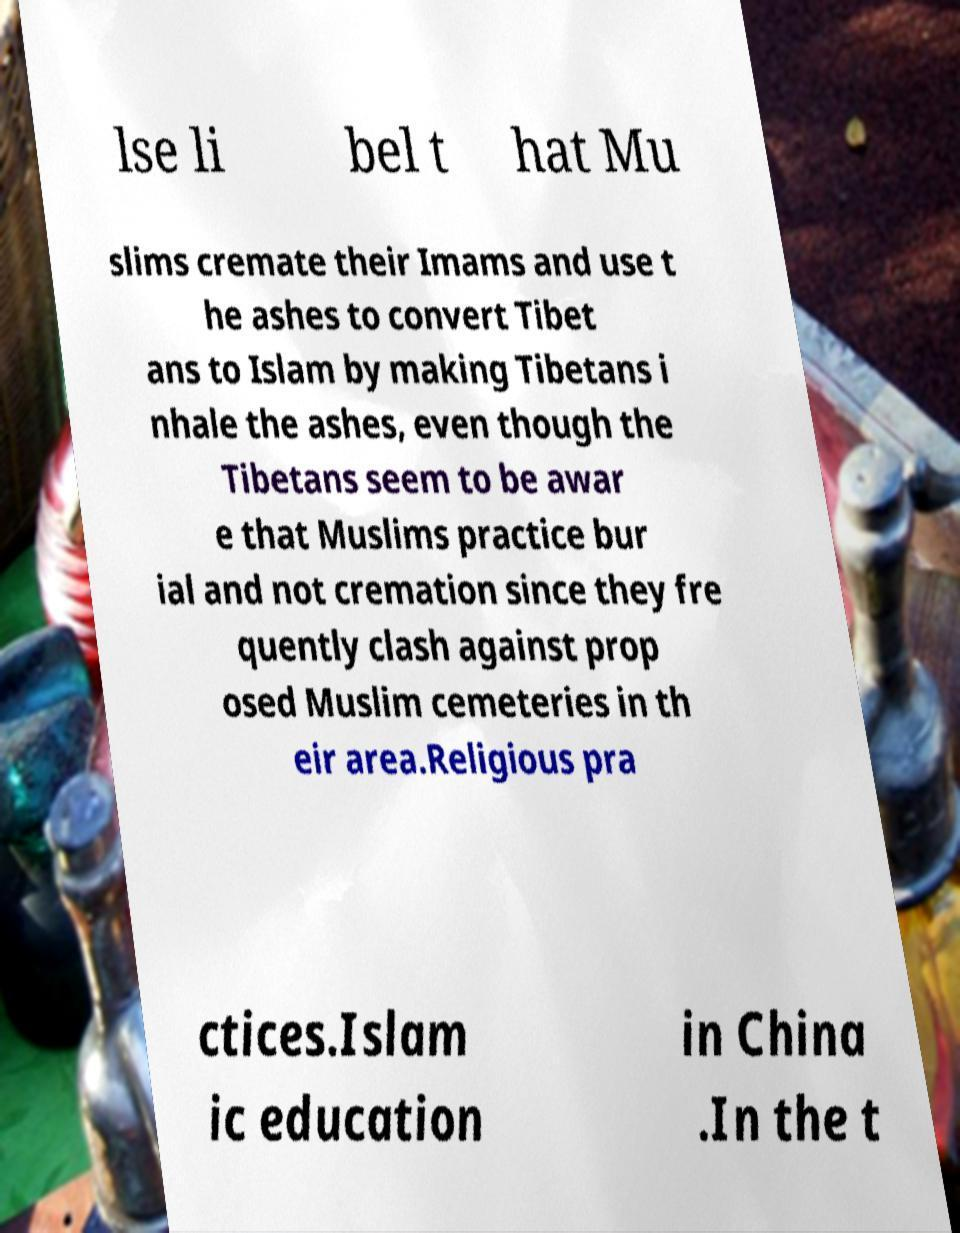I need the written content from this picture converted into text. Can you do that? lse li bel t hat Mu slims cremate their Imams and use t he ashes to convert Tibet ans to Islam by making Tibetans i nhale the ashes, even though the Tibetans seem to be awar e that Muslims practice bur ial and not cremation since they fre quently clash against prop osed Muslim cemeteries in th eir area.Religious pra ctices.Islam ic education in China .In the t 